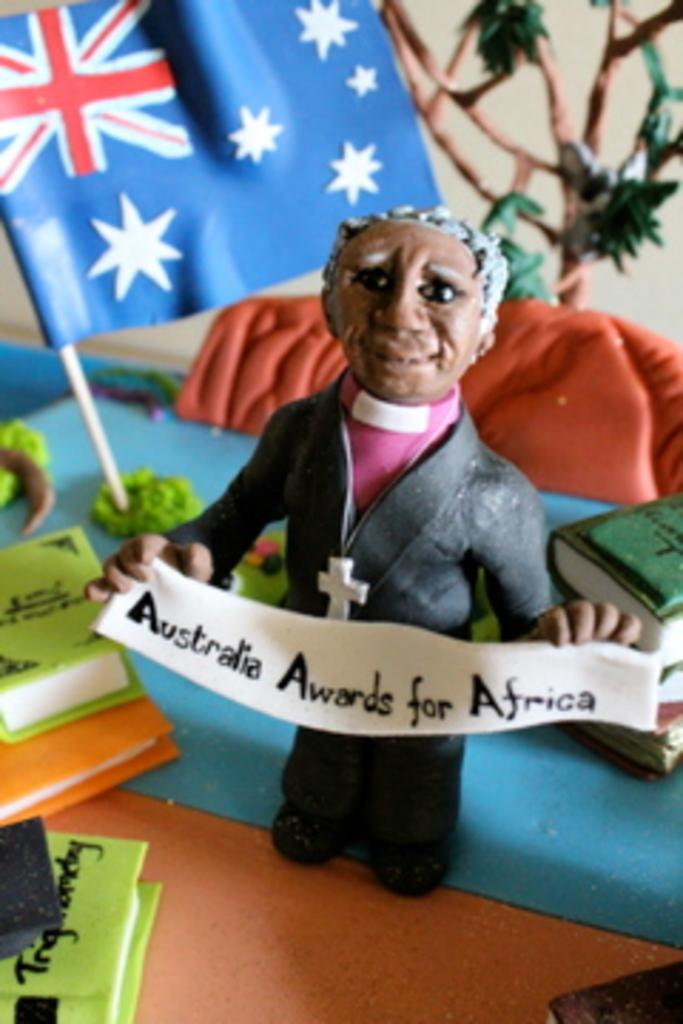What is the main subject of the image? There is a miniature of a man in the image. What else can be seen in the image besides the miniature man? There is a flag and books in the image. What type of grain is being harvested in the field shown in the image? There is no field or grain present in the image; it features a miniature man, a flag, and books. 